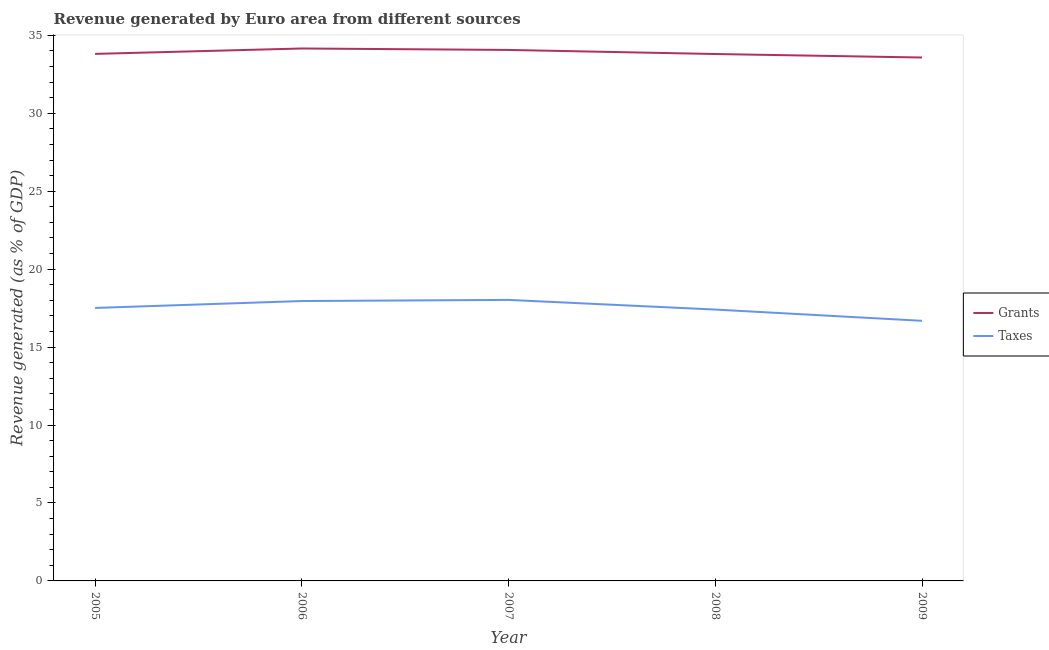How many different coloured lines are there?
Make the answer very short. 2. Does the line corresponding to revenue generated by taxes intersect with the line corresponding to revenue generated by grants?
Ensure brevity in your answer.  No. Is the number of lines equal to the number of legend labels?
Your answer should be compact. Yes. What is the revenue generated by grants in 2007?
Ensure brevity in your answer.  34.06. Across all years, what is the maximum revenue generated by grants?
Ensure brevity in your answer.  34.15. Across all years, what is the minimum revenue generated by grants?
Your response must be concise. 33.58. In which year was the revenue generated by taxes minimum?
Provide a short and direct response. 2009. What is the total revenue generated by grants in the graph?
Provide a succinct answer. 169.4. What is the difference between the revenue generated by grants in 2005 and that in 2009?
Make the answer very short. 0.23. What is the difference between the revenue generated by taxes in 2005 and the revenue generated by grants in 2009?
Keep it short and to the point. -16.06. What is the average revenue generated by taxes per year?
Provide a succinct answer. 17.52. In the year 2009, what is the difference between the revenue generated by taxes and revenue generated by grants?
Provide a succinct answer. -16.89. In how many years, is the revenue generated by taxes greater than 1 %?
Offer a very short reply. 5. What is the ratio of the revenue generated by grants in 2005 to that in 2007?
Provide a succinct answer. 0.99. Is the revenue generated by taxes in 2005 less than that in 2006?
Offer a terse response. Yes. Is the difference between the revenue generated by grants in 2005 and 2006 greater than the difference between the revenue generated by taxes in 2005 and 2006?
Your response must be concise. Yes. What is the difference between the highest and the second highest revenue generated by taxes?
Provide a short and direct response. 0.07. What is the difference between the highest and the lowest revenue generated by taxes?
Ensure brevity in your answer.  1.34. Is the sum of the revenue generated by grants in 2006 and 2008 greater than the maximum revenue generated by taxes across all years?
Your answer should be compact. Yes. How many lines are there?
Your answer should be compact. 2. Are the values on the major ticks of Y-axis written in scientific E-notation?
Your response must be concise. No. What is the title of the graph?
Provide a short and direct response. Revenue generated by Euro area from different sources. What is the label or title of the Y-axis?
Provide a succinct answer. Revenue generated (as % of GDP). What is the Revenue generated (as % of GDP) of Grants in 2005?
Ensure brevity in your answer.  33.81. What is the Revenue generated (as % of GDP) of Taxes in 2005?
Offer a terse response. 17.51. What is the Revenue generated (as % of GDP) in Grants in 2006?
Provide a short and direct response. 34.15. What is the Revenue generated (as % of GDP) in Taxes in 2006?
Provide a succinct answer. 17.95. What is the Revenue generated (as % of GDP) of Grants in 2007?
Your response must be concise. 34.06. What is the Revenue generated (as % of GDP) in Taxes in 2007?
Keep it short and to the point. 18.03. What is the Revenue generated (as % of GDP) in Grants in 2008?
Give a very brief answer. 33.8. What is the Revenue generated (as % of GDP) in Taxes in 2008?
Your answer should be compact. 17.41. What is the Revenue generated (as % of GDP) of Grants in 2009?
Offer a terse response. 33.58. What is the Revenue generated (as % of GDP) in Taxes in 2009?
Provide a short and direct response. 16.69. Across all years, what is the maximum Revenue generated (as % of GDP) in Grants?
Your response must be concise. 34.15. Across all years, what is the maximum Revenue generated (as % of GDP) in Taxes?
Give a very brief answer. 18.03. Across all years, what is the minimum Revenue generated (as % of GDP) in Grants?
Provide a succinct answer. 33.58. Across all years, what is the minimum Revenue generated (as % of GDP) in Taxes?
Offer a very short reply. 16.69. What is the total Revenue generated (as % of GDP) of Grants in the graph?
Your answer should be compact. 169.4. What is the total Revenue generated (as % of GDP) of Taxes in the graph?
Your answer should be compact. 87.59. What is the difference between the Revenue generated (as % of GDP) of Grants in 2005 and that in 2006?
Make the answer very short. -0.35. What is the difference between the Revenue generated (as % of GDP) of Taxes in 2005 and that in 2006?
Make the answer very short. -0.44. What is the difference between the Revenue generated (as % of GDP) in Grants in 2005 and that in 2007?
Your answer should be very brief. -0.25. What is the difference between the Revenue generated (as % of GDP) of Taxes in 2005 and that in 2007?
Ensure brevity in your answer.  -0.52. What is the difference between the Revenue generated (as % of GDP) of Grants in 2005 and that in 2008?
Offer a terse response. 0.01. What is the difference between the Revenue generated (as % of GDP) of Taxes in 2005 and that in 2008?
Keep it short and to the point. 0.1. What is the difference between the Revenue generated (as % of GDP) of Grants in 2005 and that in 2009?
Provide a short and direct response. 0.23. What is the difference between the Revenue generated (as % of GDP) of Taxes in 2005 and that in 2009?
Offer a terse response. 0.82. What is the difference between the Revenue generated (as % of GDP) in Grants in 2006 and that in 2007?
Ensure brevity in your answer.  0.09. What is the difference between the Revenue generated (as % of GDP) in Taxes in 2006 and that in 2007?
Provide a short and direct response. -0.07. What is the difference between the Revenue generated (as % of GDP) in Grants in 2006 and that in 2008?
Offer a very short reply. 0.35. What is the difference between the Revenue generated (as % of GDP) of Taxes in 2006 and that in 2008?
Make the answer very short. 0.55. What is the difference between the Revenue generated (as % of GDP) in Grants in 2006 and that in 2009?
Keep it short and to the point. 0.58. What is the difference between the Revenue generated (as % of GDP) of Taxes in 2006 and that in 2009?
Provide a succinct answer. 1.27. What is the difference between the Revenue generated (as % of GDP) of Grants in 2007 and that in 2008?
Provide a succinct answer. 0.26. What is the difference between the Revenue generated (as % of GDP) in Taxes in 2007 and that in 2008?
Ensure brevity in your answer.  0.62. What is the difference between the Revenue generated (as % of GDP) of Grants in 2007 and that in 2009?
Provide a succinct answer. 0.49. What is the difference between the Revenue generated (as % of GDP) in Taxes in 2007 and that in 2009?
Ensure brevity in your answer.  1.34. What is the difference between the Revenue generated (as % of GDP) of Grants in 2008 and that in 2009?
Keep it short and to the point. 0.22. What is the difference between the Revenue generated (as % of GDP) in Taxes in 2008 and that in 2009?
Provide a short and direct response. 0.72. What is the difference between the Revenue generated (as % of GDP) in Grants in 2005 and the Revenue generated (as % of GDP) in Taxes in 2006?
Offer a very short reply. 15.85. What is the difference between the Revenue generated (as % of GDP) in Grants in 2005 and the Revenue generated (as % of GDP) in Taxes in 2007?
Your answer should be very brief. 15.78. What is the difference between the Revenue generated (as % of GDP) of Grants in 2005 and the Revenue generated (as % of GDP) of Taxes in 2008?
Provide a short and direct response. 16.4. What is the difference between the Revenue generated (as % of GDP) of Grants in 2005 and the Revenue generated (as % of GDP) of Taxes in 2009?
Ensure brevity in your answer.  17.12. What is the difference between the Revenue generated (as % of GDP) in Grants in 2006 and the Revenue generated (as % of GDP) in Taxes in 2007?
Your answer should be compact. 16.13. What is the difference between the Revenue generated (as % of GDP) of Grants in 2006 and the Revenue generated (as % of GDP) of Taxes in 2008?
Keep it short and to the point. 16.75. What is the difference between the Revenue generated (as % of GDP) of Grants in 2006 and the Revenue generated (as % of GDP) of Taxes in 2009?
Offer a terse response. 17.47. What is the difference between the Revenue generated (as % of GDP) in Grants in 2007 and the Revenue generated (as % of GDP) in Taxes in 2008?
Make the answer very short. 16.65. What is the difference between the Revenue generated (as % of GDP) in Grants in 2007 and the Revenue generated (as % of GDP) in Taxes in 2009?
Keep it short and to the point. 17.38. What is the difference between the Revenue generated (as % of GDP) of Grants in 2008 and the Revenue generated (as % of GDP) of Taxes in 2009?
Provide a succinct answer. 17.11. What is the average Revenue generated (as % of GDP) of Grants per year?
Keep it short and to the point. 33.88. What is the average Revenue generated (as % of GDP) in Taxes per year?
Make the answer very short. 17.52. In the year 2005, what is the difference between the Revenue generated (as % of GDP) in Grants and Revenue generated (as % of GDP) in Taxes?
Keep it short and to the point. 16.3. In the year 2007, what is the difference between the Revenue generated (as % of GDP) in Grants and Revenue generated (as % of GDP) in Taxes?
Give a very brief answer. 16.04. In the year 2008, what is the difference between the Revenue generated (as % of GDP) in Grants and Revenue generated (as % of GDP) in Taxes?
Give a very brief answer. 16.39. In the year 2009, what is the difference between the Revenue generated (as % of GDP) of Grants and Revenue generated (as % of GDP) of Taxes?
Your answer should be very brief. 16.89. What is the ratio of the Revenue generated (as % of GDP) of Grants in 2005 to that in 2006?
Offer a terse response. 0.99. What is the ratio of the Revenue generated (as % of GDP) in Taxes in 2005 to that in 2006?
Give a very brief answer. 0.98. What is the ratio of the Revenue generated (as % of GDP) in Grants in 2005 to that in 2007?
Make the answer very short. 0.99. What is the ratio of the Revenue generated (as % of GDP) in Taxes in 2005 to that in 2007?
Offer a terse response. 0.97. What is the ratio of the Revenue generated (as % of GDP) of Grants in 2005 to that in 2008?
Your answer should be very brief. 1. What is the ratio of the Revenue generated (as % of GDP) in Taxes in 2005 to that in 2008?
Keep it short and to the point. 1.01. What is the ratio of the Revenue generated (as % of GDP) of Taxes in 2005 to that in 2009?
Keep it short and to the point. 1.05. What is the ratio of the Revenue generated (as % of GDP) of Taxes in 2006 to that in 2007?
Ensure brevity in your answer.  1. What is the ratio of the Revenue generated (as % of GDP) in Grants in 2006 to that in 2008?
Make the answer very short. 1.01. What is the ratio of the Revenue generated (as % of GDP) of Taxes in 2006 to that in 2008?
Make the answer very short. 1.03. What is the ratio of the Revenue generated (as % of GDP) of Grants in 2006 to that in 2009?
Your answer should be very brief. 1.02. What is the ratio of the Revenue generated (as % of GDP) in Taxes in 2006 to that in 2009?
Give a very brief answer. 1.08. What is the ratio of the Revenue generated (as % of GDP) in Grants in 2007 to that in 2008?
Your answer should be very brief. 1.01. What is the ratio of the Revenue generated (as % of GDP) in Taxes in 2007 to that in 2008?
Your answer should be compact. 1.04. What is the ratio of the Revenue generated (as % of GDP) of Grants in 2007 to that in 2009?
Provide a short and direct response. 1.01. What is the ratio of the Revenue generated (as % of GDP) in Taxes in 2007 to that in 2009?
Offer a very short reply. 1.08. What is the ratio of the Revenue generated (as % of GDP) of Taxes in 2008 to that in 2009?
Your response must be concise. 1.04. What is the difference between the highest and the second highest Revenue generated (as % of GDP) of Grants?
Make the answer very short. 0.09. What is the difference between the highest and the second highest Revenue generated (as % of GDP) of Taxes?
Offer a terse response. 0.07. What is the difference between the highest and the lowest Revenue generated (as % of GDP) in Grants?
Give a very brief answer. 0.58. What is the difference between the highest and the lowest Revenue generated (as % of GDP) in Taxes?
Offer a terse response. 1.34. 